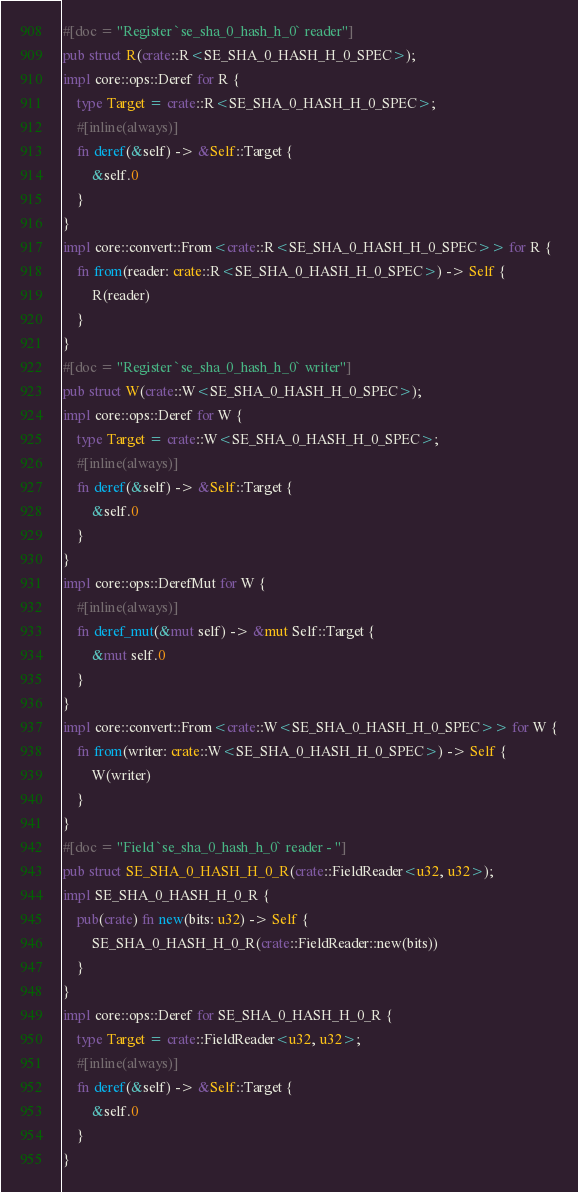Convert code to text. <code><loc_0><loc_0><loc_500><loc_500><_Rust_>#[doc = "Register `se_sha_0_hash_h_0` reader"]
pub struct R(crate::R<SE_SHA_0_HASH_H_0_SPEC>);
impl core::ops::Deref for R {
    type Target = crate::R<SE_SHA_0_HASH_H_0_SPEC>;
    #[inline(always)]
    fn deref(&self) -> &Self::Target {
        &self.0
    }
}
impl core::convert::From<crate::R<SE_SHA_0_HASH_H_0_SPEC>> for R {
    fn from(reader: crate::R<SE_SHA_0_HASH_H_0_SPEC>) -> Self {
        R(reader)
    }
}
#[doc = "Register `se_sha_0_hash_h_0` writer"]
pub struct W(crate::W<SE_SHA_0_HASH_H_0_SPEC>);
impl core::ops::Deref for W {
    type Target = crate::W<SE_SHA_0_HASH_H_0_SPEC>;
    #[inline(always)]
    fn deref(&self) -> &Self::Target {
        &self.0
    }
}
impl core::ops::DerefMut for W {
    #[inline(always)]
    fn deref_mut(&mut self) -> &mut Self::Target {
        &mut self.0
    }
}
impl core::convert::From<crate::W<SE_SHA_0_HASH_H_0_SPEC>> for W {
    fn from(writer: crate::W<SE_SHA_0_HASH_H_0_SPEC>) -> Self {
        W(writer)
    }
}
#[doc = "Field `se_sha_0_hash_h_0` reader - "]
pub struct SE_SHA_0_HASH_H_0_R(crate::FieldReader<u32, u32>);
impl SE_SHA_0_HASH_H_0_R {
    pub(crate) fn new(bits: u32) -> Self {
        SE_SHA_0_HASH_H_0_R(crate::FieldReader::new(bits))
    }
}
impl core::ops::Deref for SE_SHA_0_HASH_H_0_R {
    type Target = crate::FieldReader<u32, u32>;
    #[inline(always)]
    fn deref(&self) -> &Self::Target {
        &self.0
    }
}</code> 